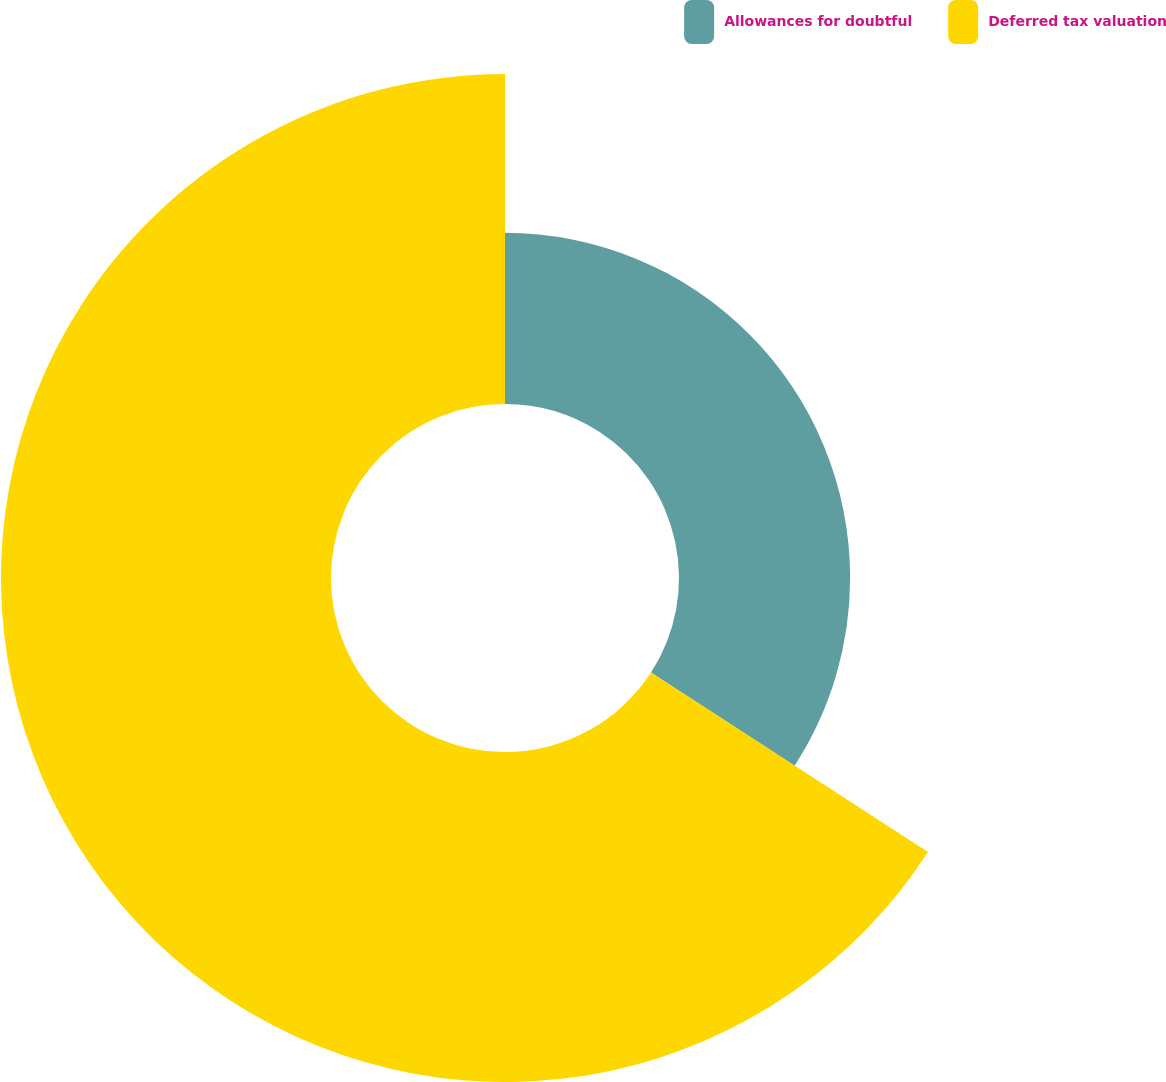Convert chart to OTSL. <chart><loc_0><loc_0><loc_500><loc_500><pie_chart><fcel>Allowances for doubtful<fcel>Deferred tax valuation<nl><fcel>34.15%<fcel>65.85%<nl></chart> 